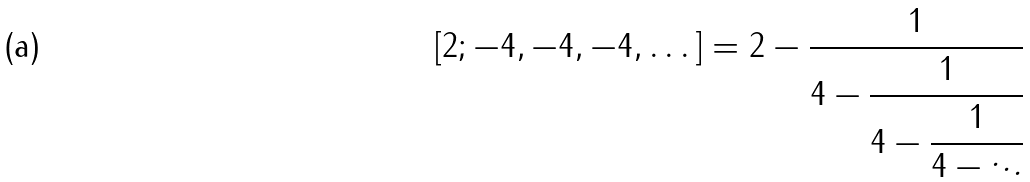<formula> <loc_0><loc_0><loc_500><loc_500>[ 2 ; - 4 , - 4 , - 4 , \dots ] = 2 - { \cfrac { 1 } { 4 - { \cfrac { 1 } { 4 - { \cfrac { 1 } { 4 - \ddots } } } } } }</formula> 